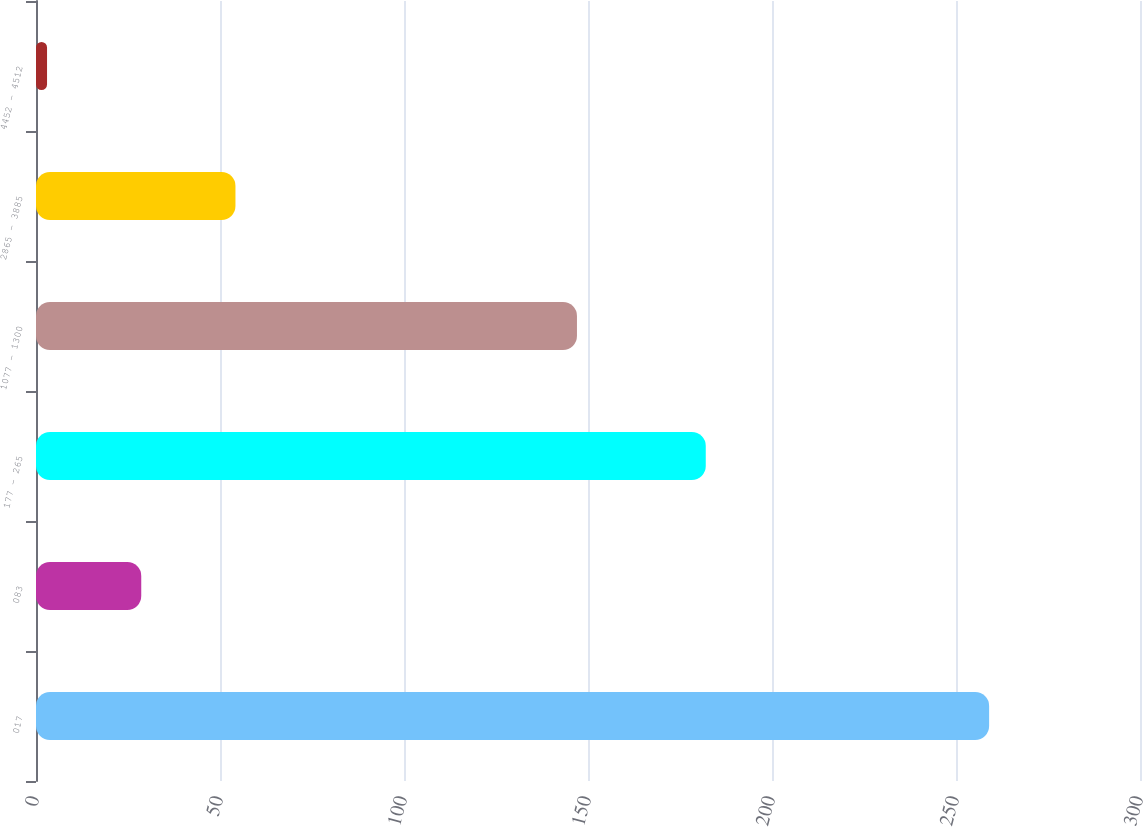Convert chart. <chart><loc_0><loc_0><loc_500><loc_500><bar_chart><fcel>017<fcel>083<fcel>177 - 265<fcel>1077 - 1300<fcel>2865 - 3885<fcel>4452 - 4512<nl><fcel>259<fcel>28.6<fcel>182<fcel>147<fcel>54.2<fcel>3<nl></chart> 